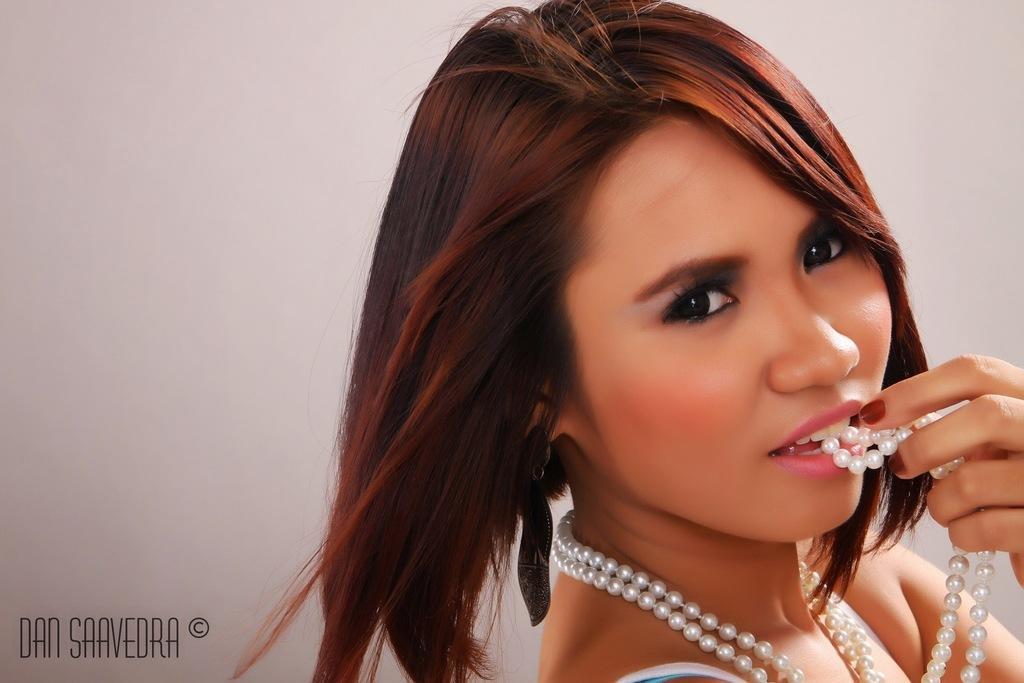Please provide a concise description of this image. In the picture we can see a woman standing and wearing a pearl necklace and holding it with hand and keeping in her mouth. 